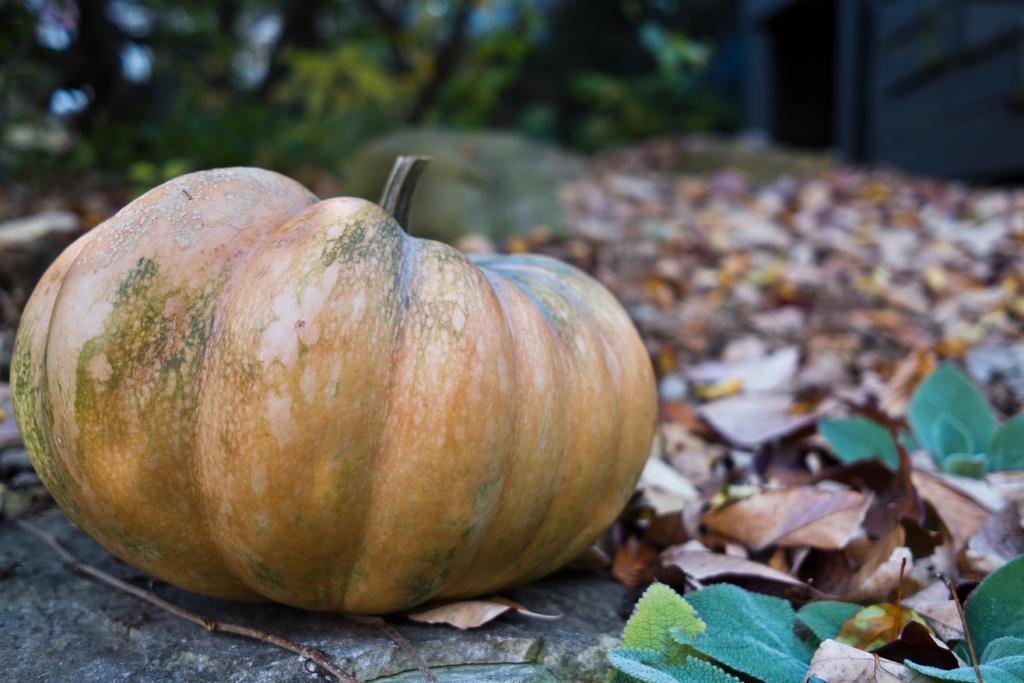In one or two sentences, can you explain what this image depicts? In this image there is a pumpkin on the rock, there are twigs towards the bottom of the image, there are plants towards the right of the image, there are plants towards the bottom of the image, there are dried leaves on the ground, there are trees towards the top of the image, there is a building towards the top of the image, there is a door, the background of the image is blurred. 